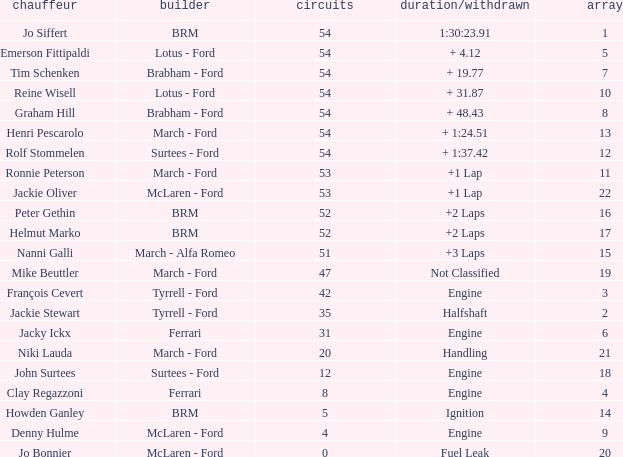How many laps for a grid larger than 1 with a Time/Retired of halfshaft? 35.0. 